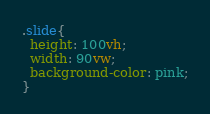Convert code to text. <code><loc_0><loc_0><loc_500><loc_500><_CSS_>.slide{
  height: 100vh;
  width: 90vw;
  background-color: pink;
}
</code> 